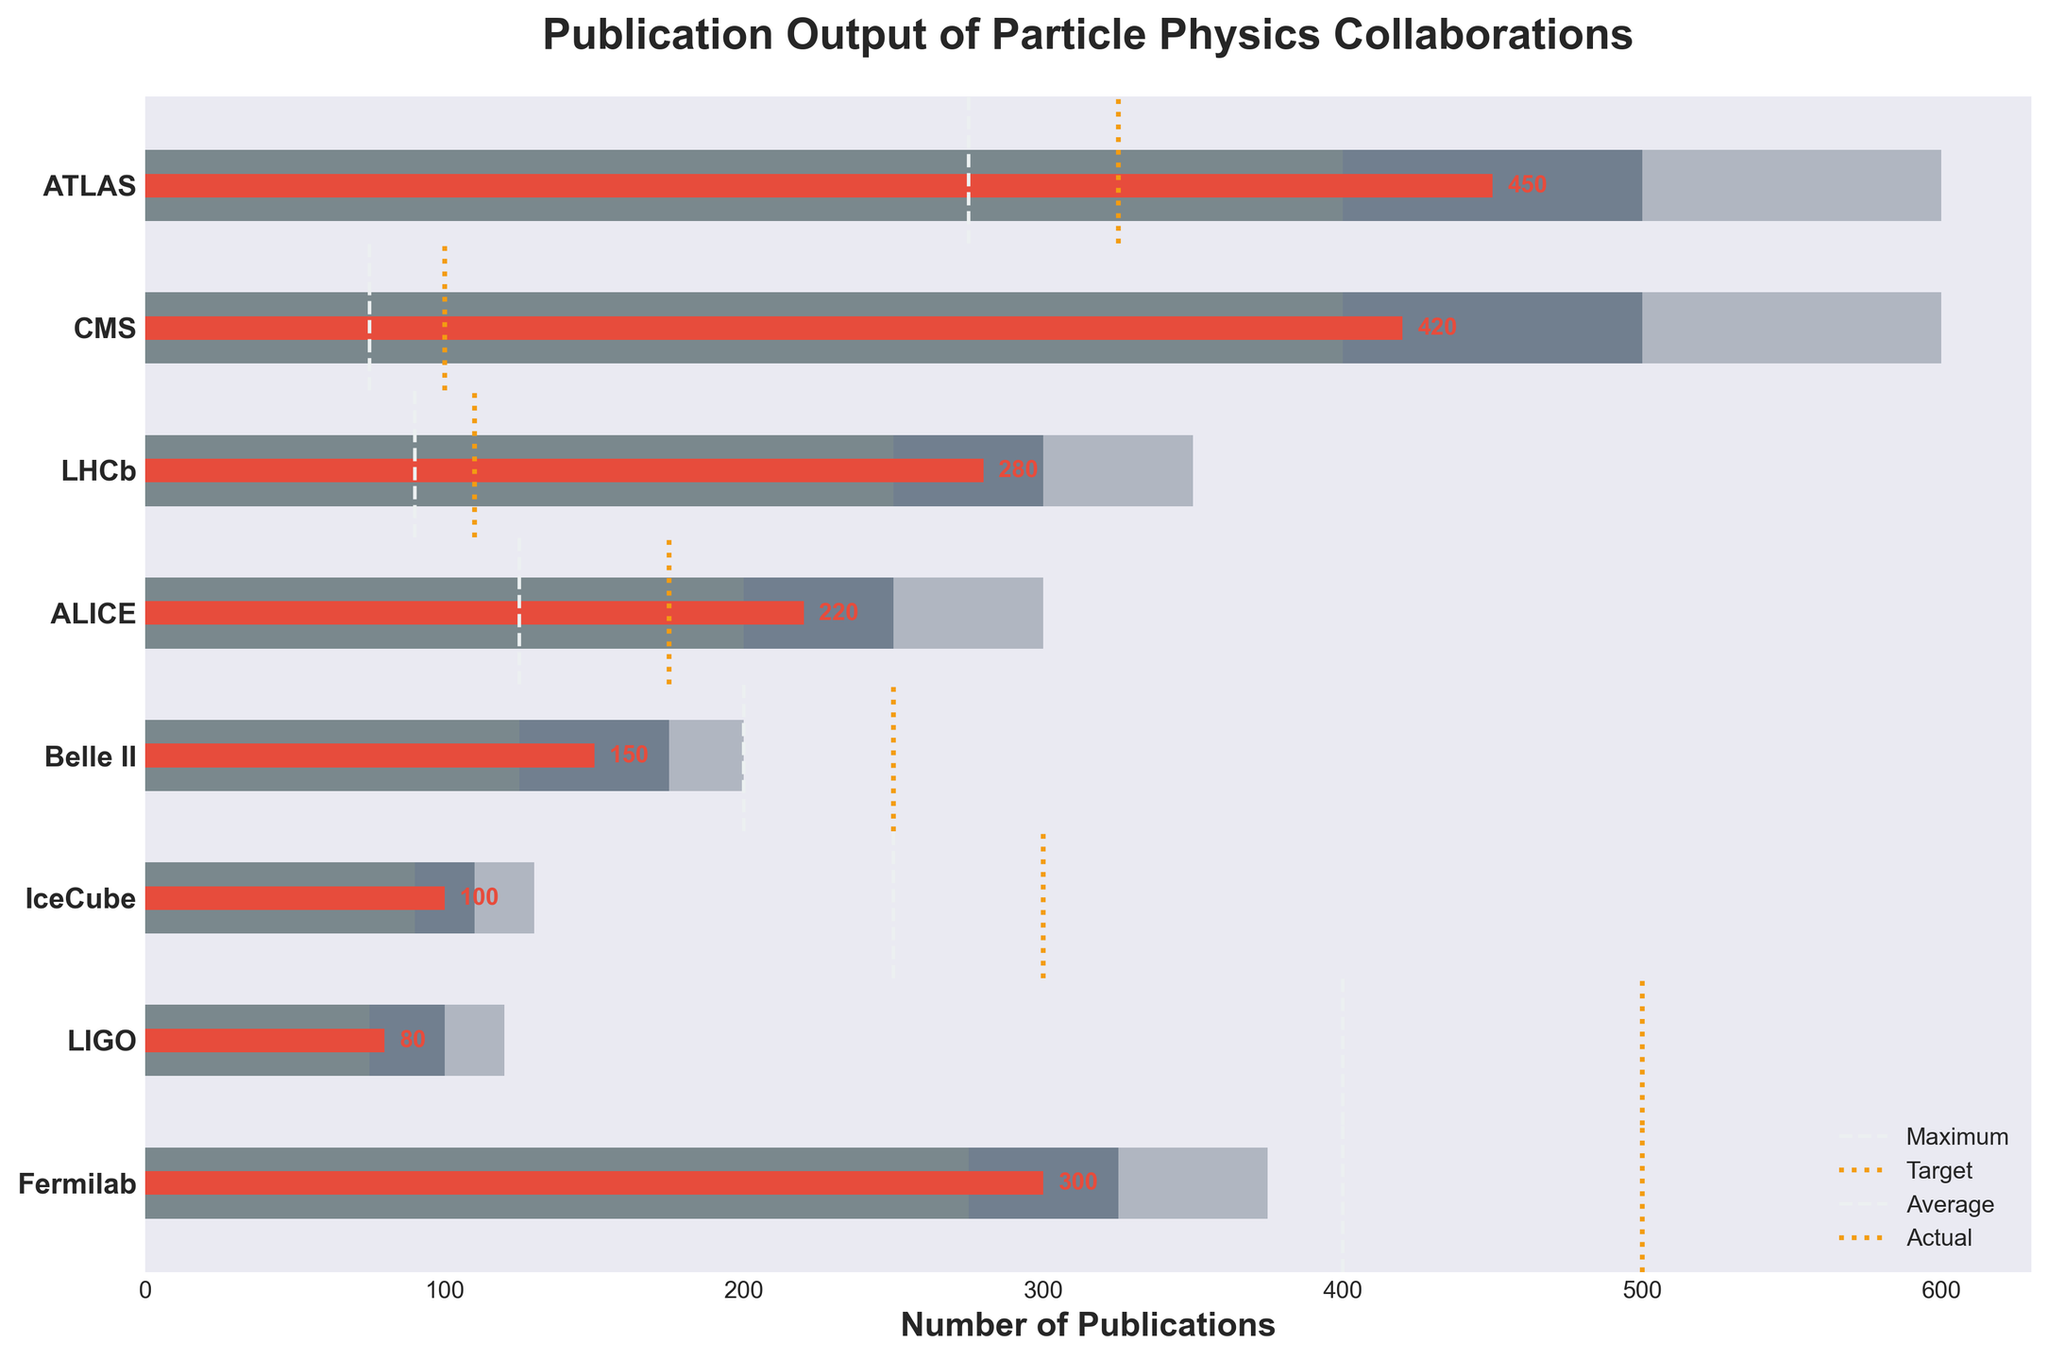What is the title of the plot? The title can be seen at the top of the figure. It reads "Publication Output of Particle Physics Collaborations."
Answer: Publication Output of Particle Physics Collaborations Which collaboration has the highest number of publications? By observing the red bars representing the actual number of publications, ATLAS is the collaboration with the longest red bar.
Answer: ATLAS How many publications did the IceCube collaboration achieve? The IceCube collaboration's publication count can be found by looking at the red bar corresponding to IceCube, which is labeled with the number "100."
Answer: 100 What is the target number of publications for the ALICE collaboration? The target value is indicated by the light orange vertical dotted line, labeled next to each collaboration. ALICE's target, labeled on its line, is “250.”
Answer: 250 How does the publication output of LHCb compare with its target? The red bar for LHCb shows its actual publications, which is 280. The target value for LHCb is indicated by the vertical dotted line next to LHCb, which is 300. The actual number of publications (280) is below the target (300).
Answer: Below target by 20 Which collaboration has the smallest number of publications? The smallest publication count is represented by the shortest red bar, which belongs to LIGO.
Answer: LIGO Is the actual number of publications for CMS above or below the average? The red bar indicates the actual publications, which is 420, while the dashed vertical line indicates the average, which is 400. The actual number (420) is above the average (400).
Answer: Above What is the difference between the maximum and the target publications for Belle II? The maximum publications for Belle II are 200 and the target is 175. Subtracting these gives the difference: 200 - 175 = 25.
Answer: 25 How many collaborations have achieved their target publication numbers? By observing and counting the red bars that extend beyond their respective dotted vertical lines (targets), we see that ATLAS and CMS have achieved their targets. Therefore, there are 2 collaborations that achieved their targets.
Answer: 2 Which collaboration has the closest actual publication count to the maximum value within their category? This can be found by looking at the red bars and their proximity to the end of the main dark gray bar for maximum value. ATLAS, with 450 publications, is closest to its maximum value of 600 publications.
Answer: ATLAS 